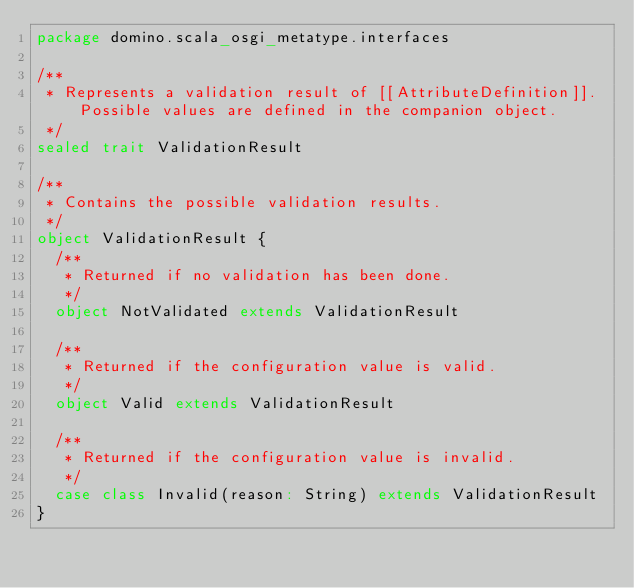Convert code to text. <code><loc_0><loc_0><loc_500><loc_500><_Scala_>package domino.scala_osgi_metatype.interfaces

/**
 * Represents a validation result of [[AttributeDefinition]]. Possible values are defined in the companion object.
 */
sealed trait ValidationResult

/**
 * Contains the possible validation results.
 */
object ValidationResult {
  /**
   * Returned if no validation has been done.
   */
  object NotValidated extends ValidationResult

  /**
   * Returned if the configuration value is valid.
   */
  object Valid extends ValidationResult

  /**
   * Returned if the configuration value is invalid.
   */
  case class Invalid(reason: String) extends ValidationResult
}
</code> 